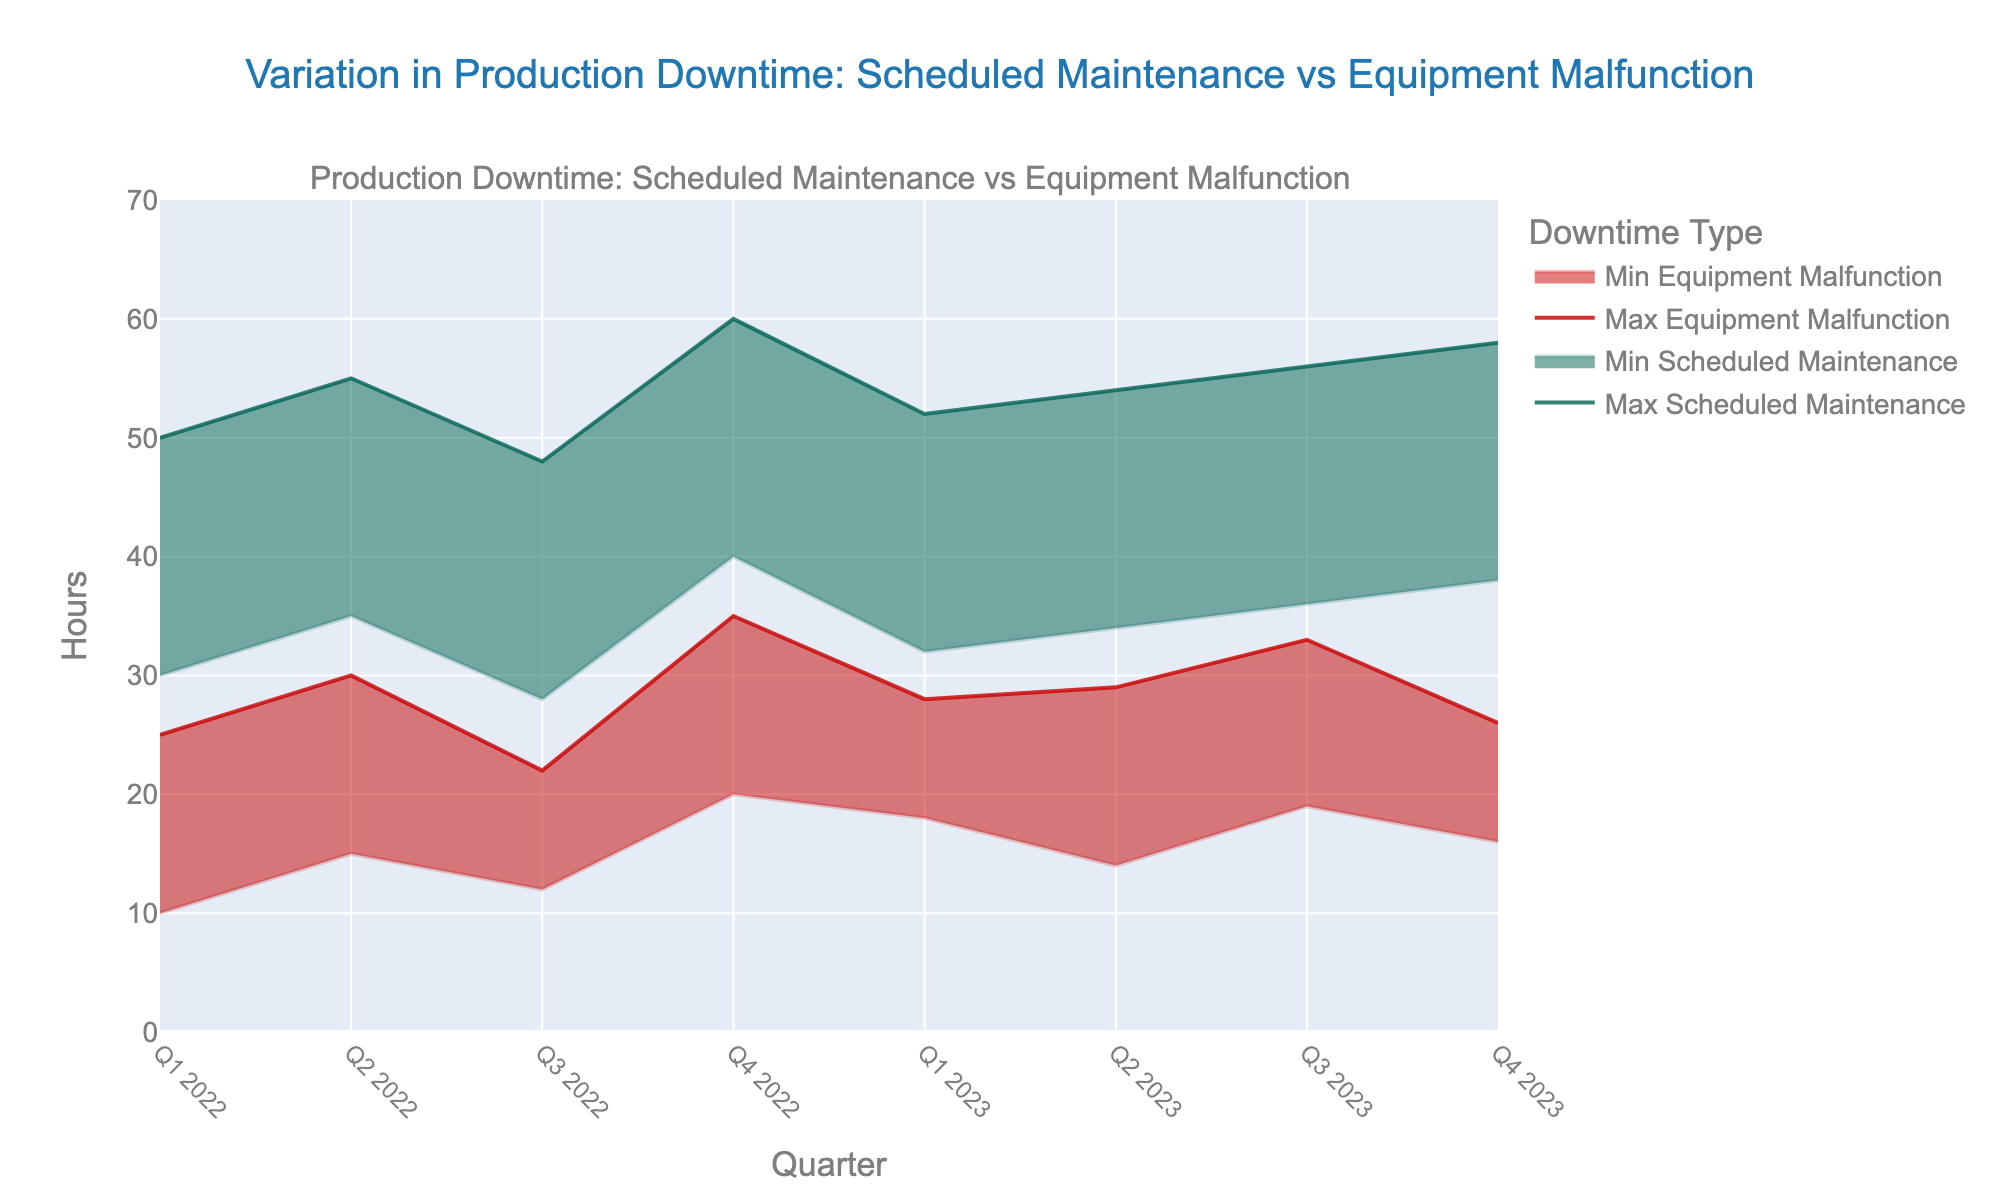What are the title and axes labels of the chart? The chart's title and axes labels are parts of the basic elements. The title is shown at the top of the chart, and the axes labels are displayed along the x-axis and y-axis.
Answer: The title of the chart is "Variation in Production Downtime: Scheduled Maintenance vs Equipment Malfunction". The x-axis label is "Quarter", and the y-axis label is "Hours" How many quarters are represented in the chart? Count the distinct data points along the x-axis, as each represents a different quarter.
Answer: There are 8 quarters represented in the chart Which quarter had the highest maximum equipment malfunction downtime? Look at the curve representing the maximum equipment malfunction hours (red line) and find the highest point.
Answer: Q4 2022 During Q3 2022, what is the range of hours for scheduled maintenance? Identify the minimum and maximum values from the range area for scheduled maintenance during Q3 2022.
Answer: The range is from 28 to 48 hours How does the maximum scheduled maintenance downtime in Q4 2022 compare to that in Q4 2023? Check the maximum values for scheduled maintenance downtime in both quarters and compare them.
Answer: The maximum scheduled maintenance downtime increased from 60 hours in Q4 2022 to 58 hours in Q4 2023 What is the difference in the maximum equipment malfunction hours between Q1 2022 and Q4 2022? Find the maximum values for equipment malfunction hours for Q1 2022 and Q4 2022, and subtract the earlier value from the later value.
Answer: The difference is 10 hours (35 - 25) Which quarter had the smallest variation in equipment malfunction hours? Determine the range (difference between max and min) of equipment malfunction hours for each quarter and identify the smallest range.
Answer: Q3 2022 had the smallest variation, with a range of 10 hours (22 - 12) Is there a general trend in the scheduled maintenance hours from Q1 2022 to Q4 2023? Observe the overall direction of the scheduled maintenance hours' area (green shaded region) over time.
Answer: Yes, there is a slight increasing trend in scheduled maintenance hours over the quarters What is the maximum difference in hours for scheduled maintenance within any single quarter? Identify the quarter with the largest difference between the maximum and minimum scheduled maintenance hours.
Answer: The maximum difference is 20 hours in Q4 2022 How does the average minimum downtime for equipment malfunctions compare across all quarters? Calculate the mean of the minimum equipment malfunction hours across all quarters.
Answer: The average minimum downtime for equipment malfunctions across all quarters is (10+15+12+20+18+14+19+16) / 8 = 15.5 hours 